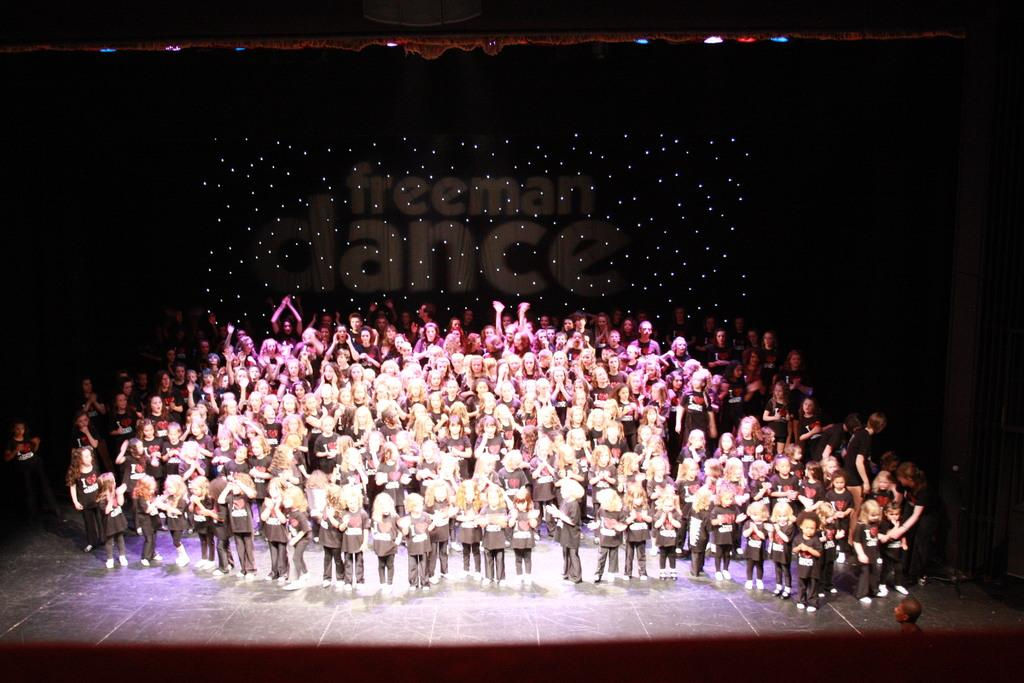How many people are in the image? There are many children in the image. Where are the children located in the image? The children are standing on a stage. What color is the background of the image? The background of the image is black. How many frogs can be seen sitting on the windowsill in the image? There are no frogs or windowsills present in the image. 